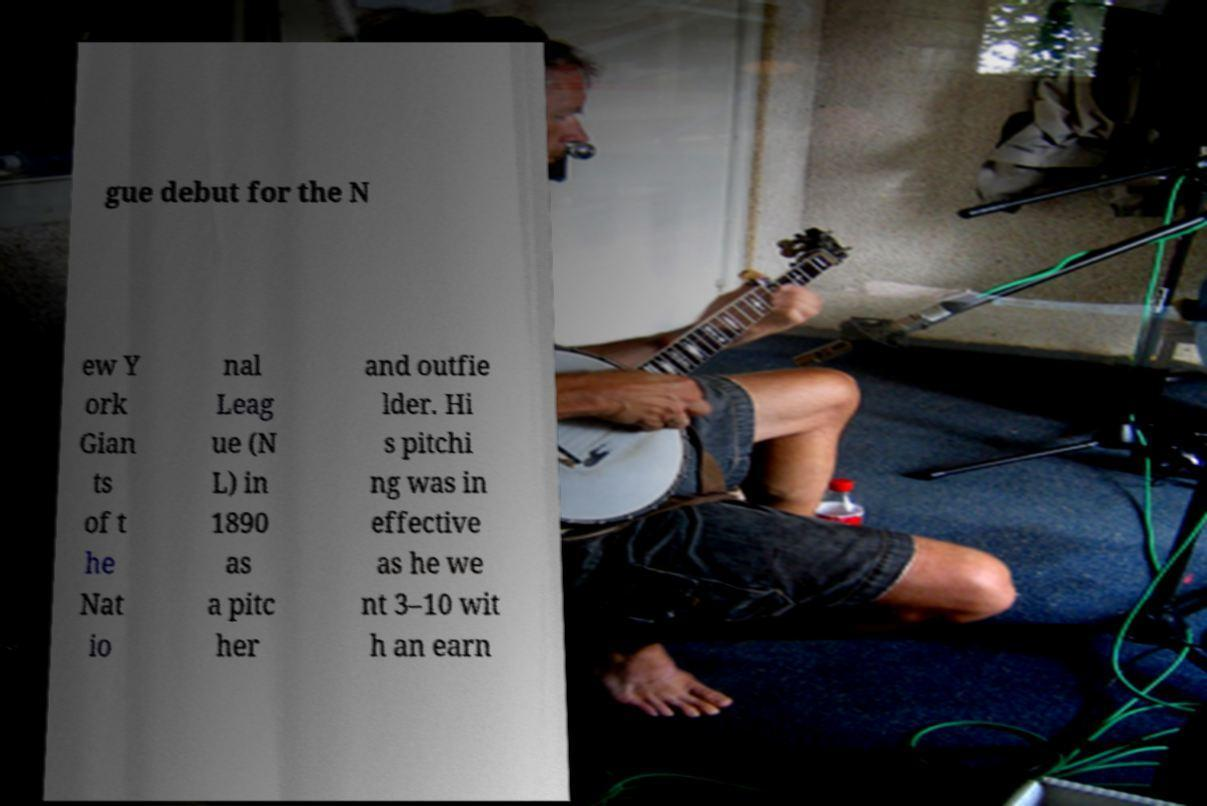There's text embedded in this image that I need extracted. Can you transcribe it verbatim? gue debut for the N ew Y ork Gian ts of t he Nat io nal Leag ue (N L) in 1890 as a pitc her and outfie lder. Hi s pitchi ng was in effective as he we nt 3–10 wit h an earn 